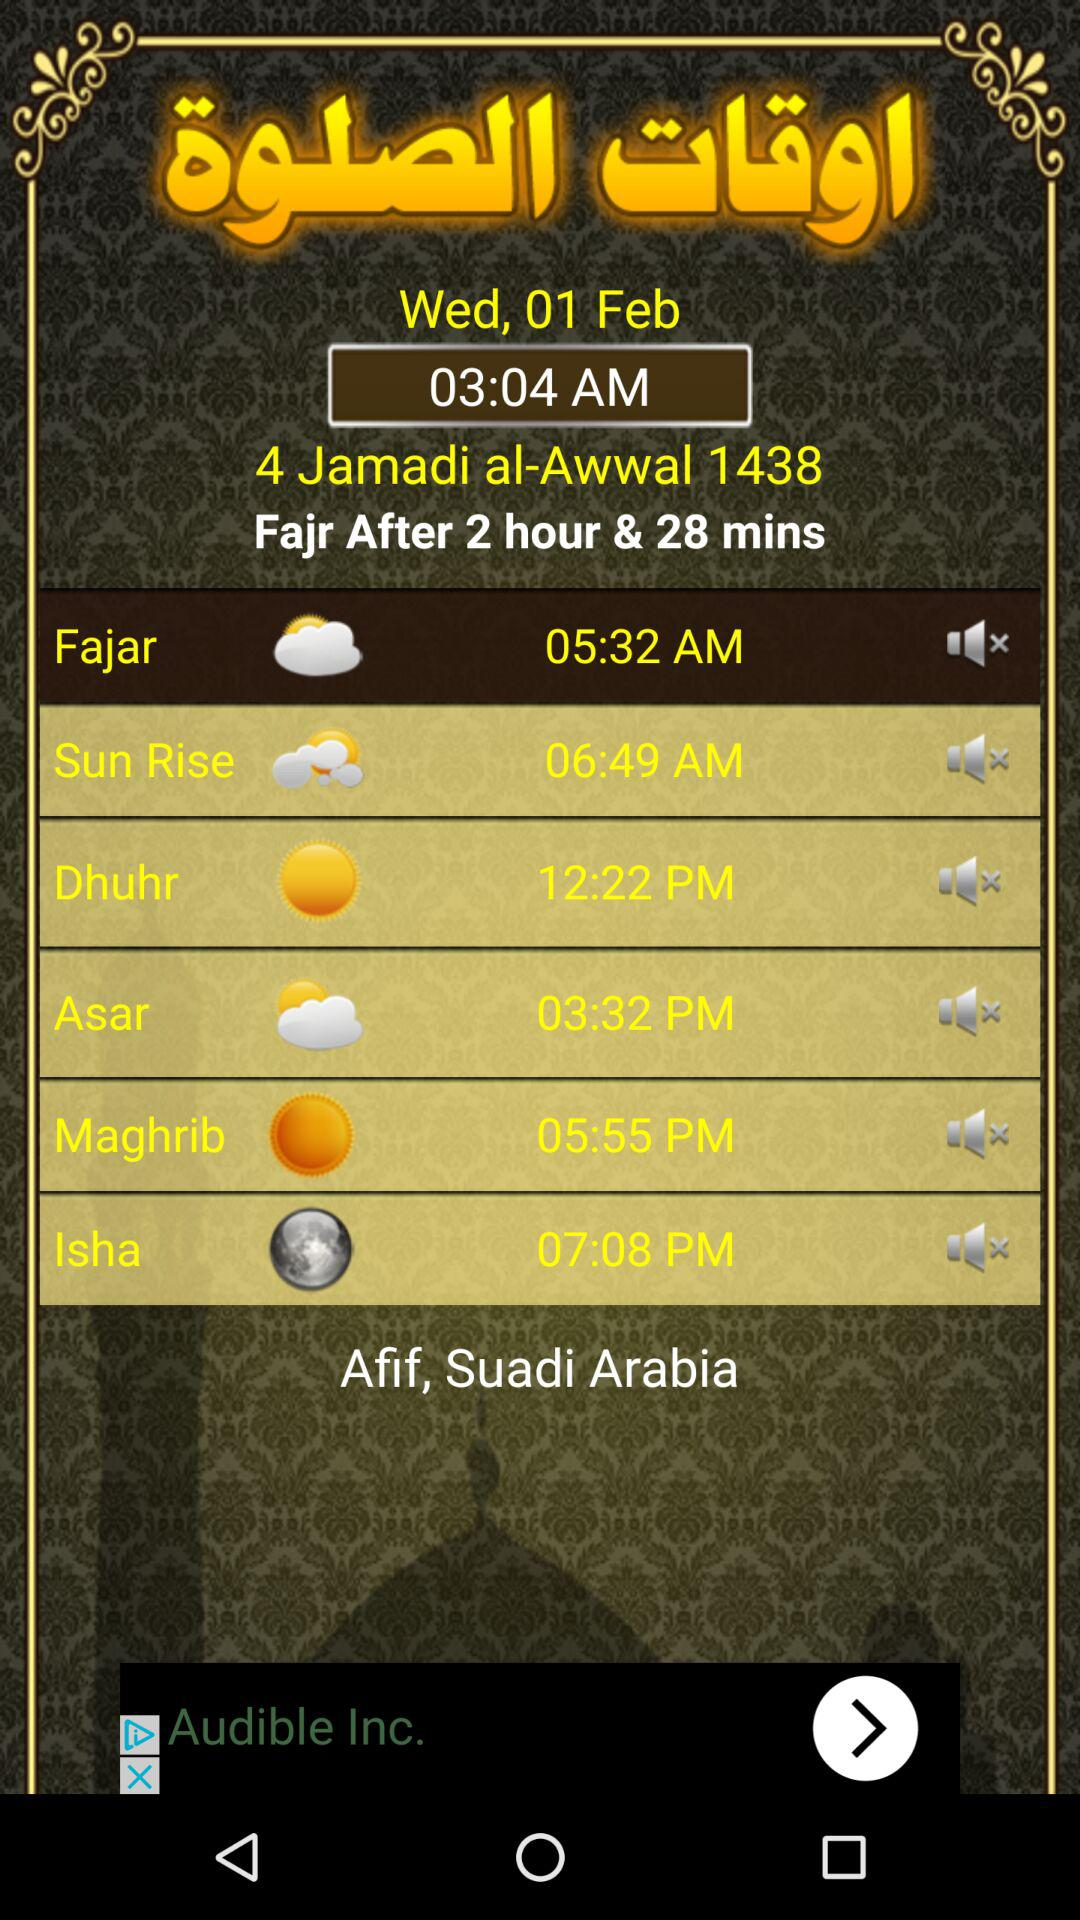What is the time of "Asar"? The time of "Asar" is 3:32 p.m. 